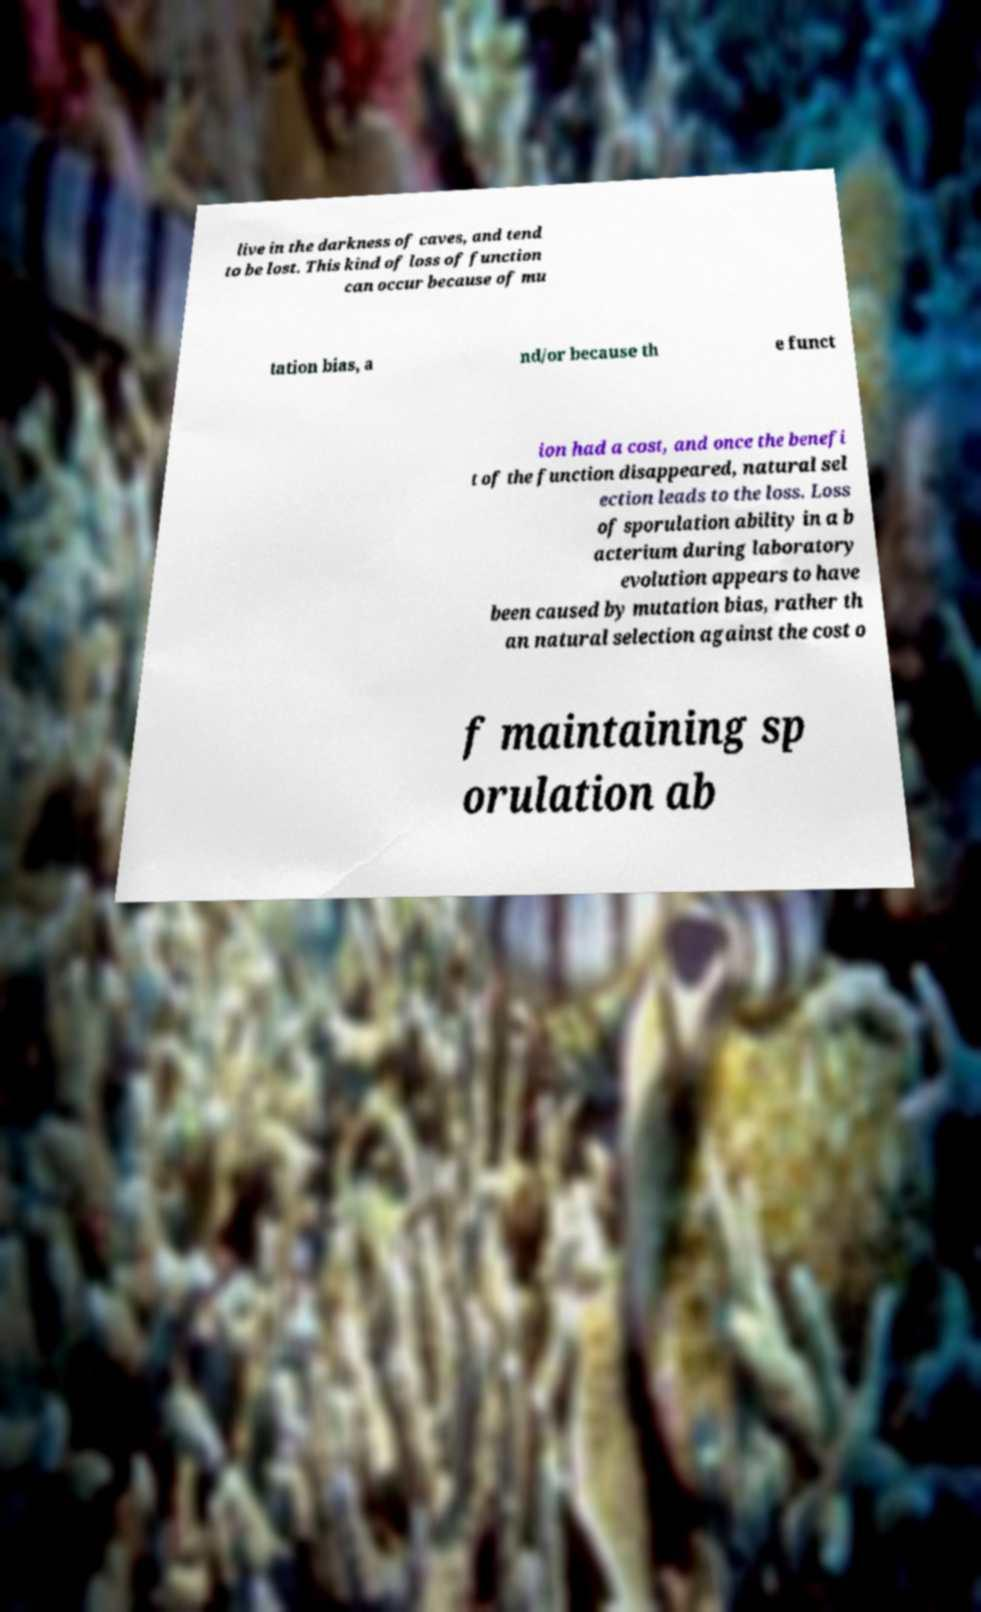Please identify and transcribe the text found in this image. live in the darkness of caves, and tend to be lost. This kind of loss of function can occur because of mu tation bias, a nd/or because th e funct ion had a cost, and once the benefi t of the function disappeared, natural sel ection leads to the loss. Loss of sporulation ability in a b acterium during laboratory evolution appears to have been caused by mutation bias, rather th an natural selection against the cost o f maintaining sp orulation ab 